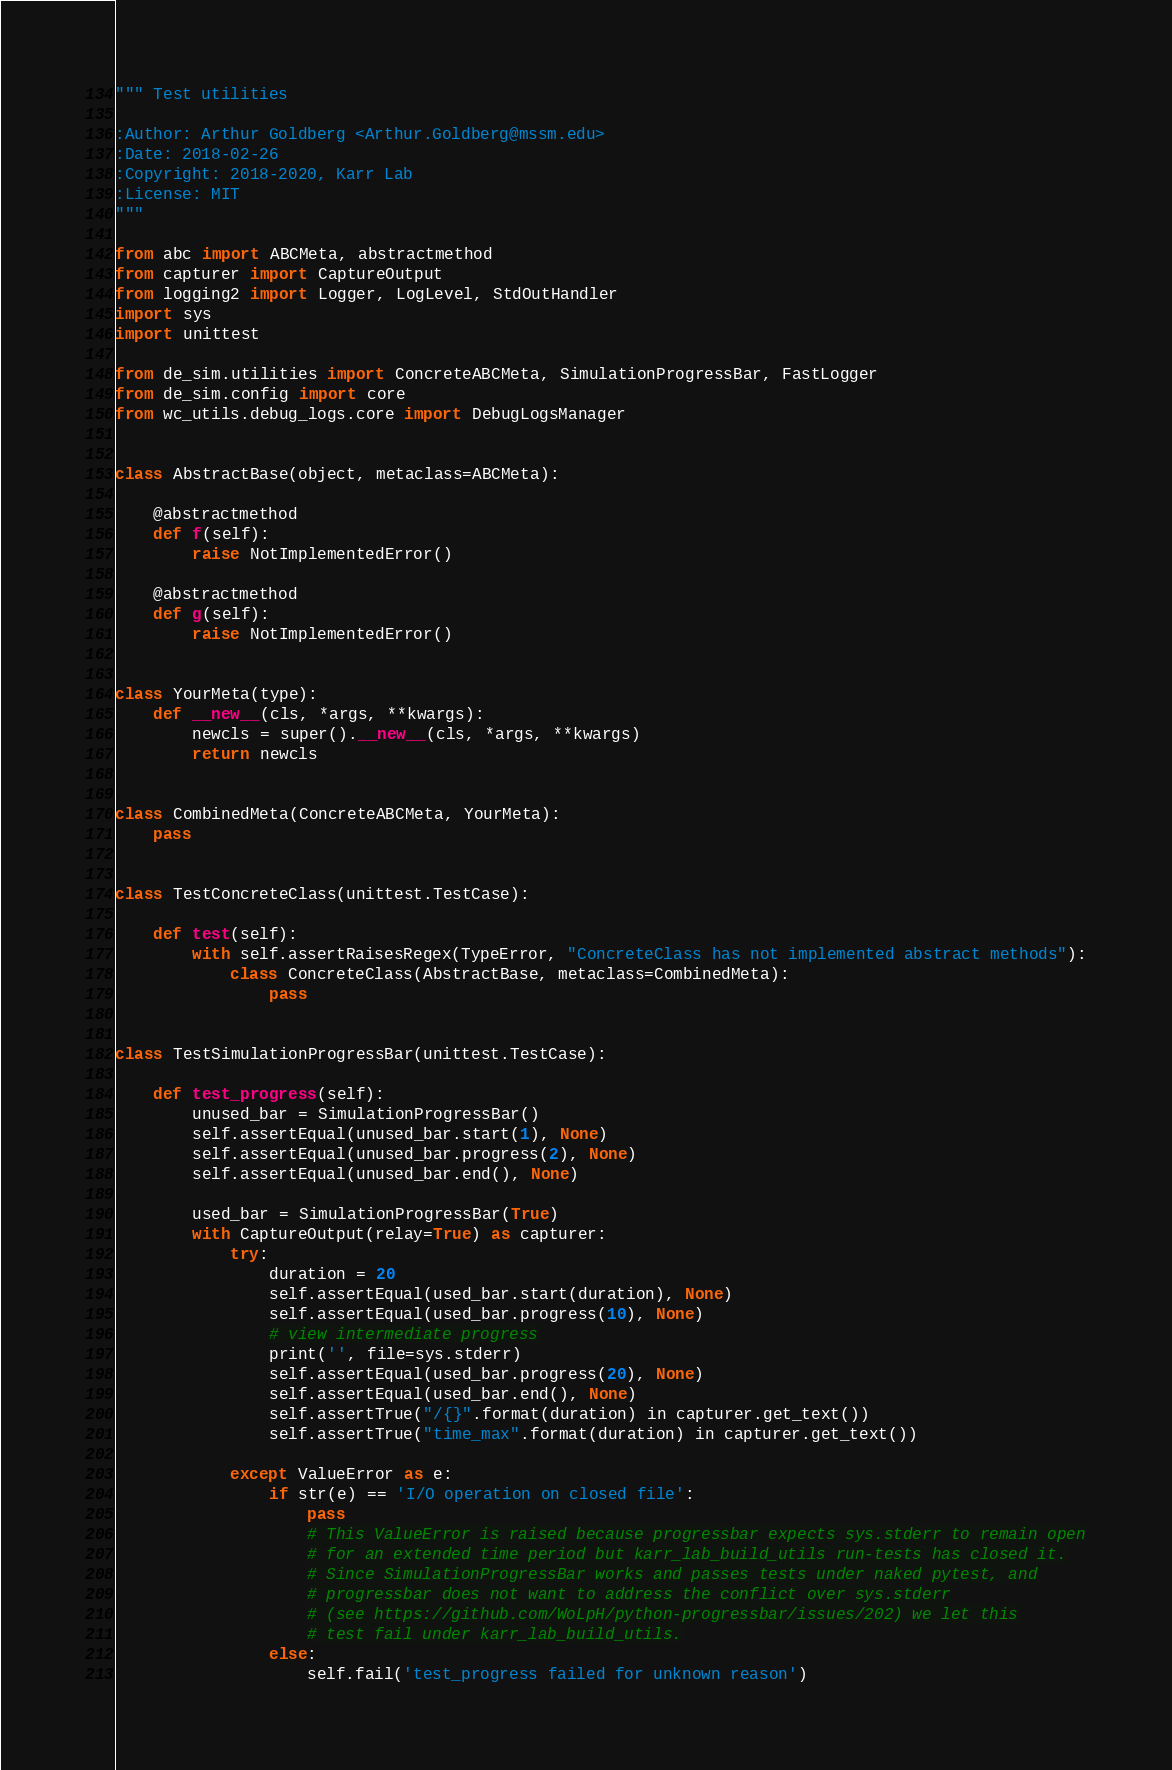<code> <loc_0><loc_0><loc_500><loc_500><_Python_>""" Test utilities

:Author: Arthur Goldberg <Arthur.Goldberg@mssm.edu>
:Date: 2018-02-26
:Copyright: 2018-2020, Karr Lab
:License: MIT
"""

from abc import ABCMeta, abstractmethod
from capturer import CaptureOutput
from logging2 import Logger, LogLevel, StdOutHandler
import sys
import unittest

from de_sim.utilities import ConcreteABCMeta, SimulationProgressBar, FastLogger
from de_sim.config import core
from wc_utils.debug_logs.core import DebugLogsManager


class AbstractBase(object, metaclass=ABCMeta):

    @abstractmethod
    def f(self):
        raise NotImplementedError()

    @abstractmethod
    def g(self):
        raise NotImplementedError()


class YourMeta(type):
    def __new__(cls, *args, **kwargs):
        newcls = super().__new__(cls, *args, **kwargs)
        return newcls


class CombinedMeta(ConcreteABCMeta, YourMeta):
    pass


class TestConcreteClass(unittest.TestCase):

    def test(self):
        with self.assertRaisesRegex(TypeError, "ConcreteClass has not implemented abstract methods"):
            class ConcreteClass(AbstractBase, metaclass=CombinedMeta):
                pass


class TestSimulationProgressBar(unittest.TestCase):

    def test_progress(self):
        unused_bar = SimulationProgressBar()
        self.assertEqual(unused_bar.start(1), None)
        self.assertEqual(unused_bar.progress(2), None)
        self.assertEqual(unused_bar.end(), None)

        used_bar = SimulationProgressBar(True)
        with CaptureOutput(relay=True) as capturer:
            try:
                duration = 20
                self.assertEqual(used_bar.start(duration), None)
                self.assertEqual(used_bar.progress(10), None)
                # view intermediate progress
                print('', file=sys.stderr)
                self.assertEqual(used_bar.progress(20), None)
                self.assertEqual(used_bar.end(), None)
                self.assertTrue("/{}".format(duration) in capturer.get_text())
                self.assertTrue("time_max".format(duration) in capturer.get_text())

            except ValueError as e:
                if str(e) == 'I/O operation on closed file':
                    pass
                    # This ValueError is raised because progressbar expects sys.stderr to remain open
                    # for an extended time period but karr_lab_build_utils run-tests has closed it.
                    # Since SimulationProgressBar works and passes tests under naked pytest, and
                    # progressbar does not want to address the conflict over sys.stderr
                    # (see https://github.com/WoLpH/python-progressbar/issues/202) we let this
                    # test fail under karr_lab_build_utils.
                else:
                    self.fail('test_progress failed for unknown reason')

</code> 